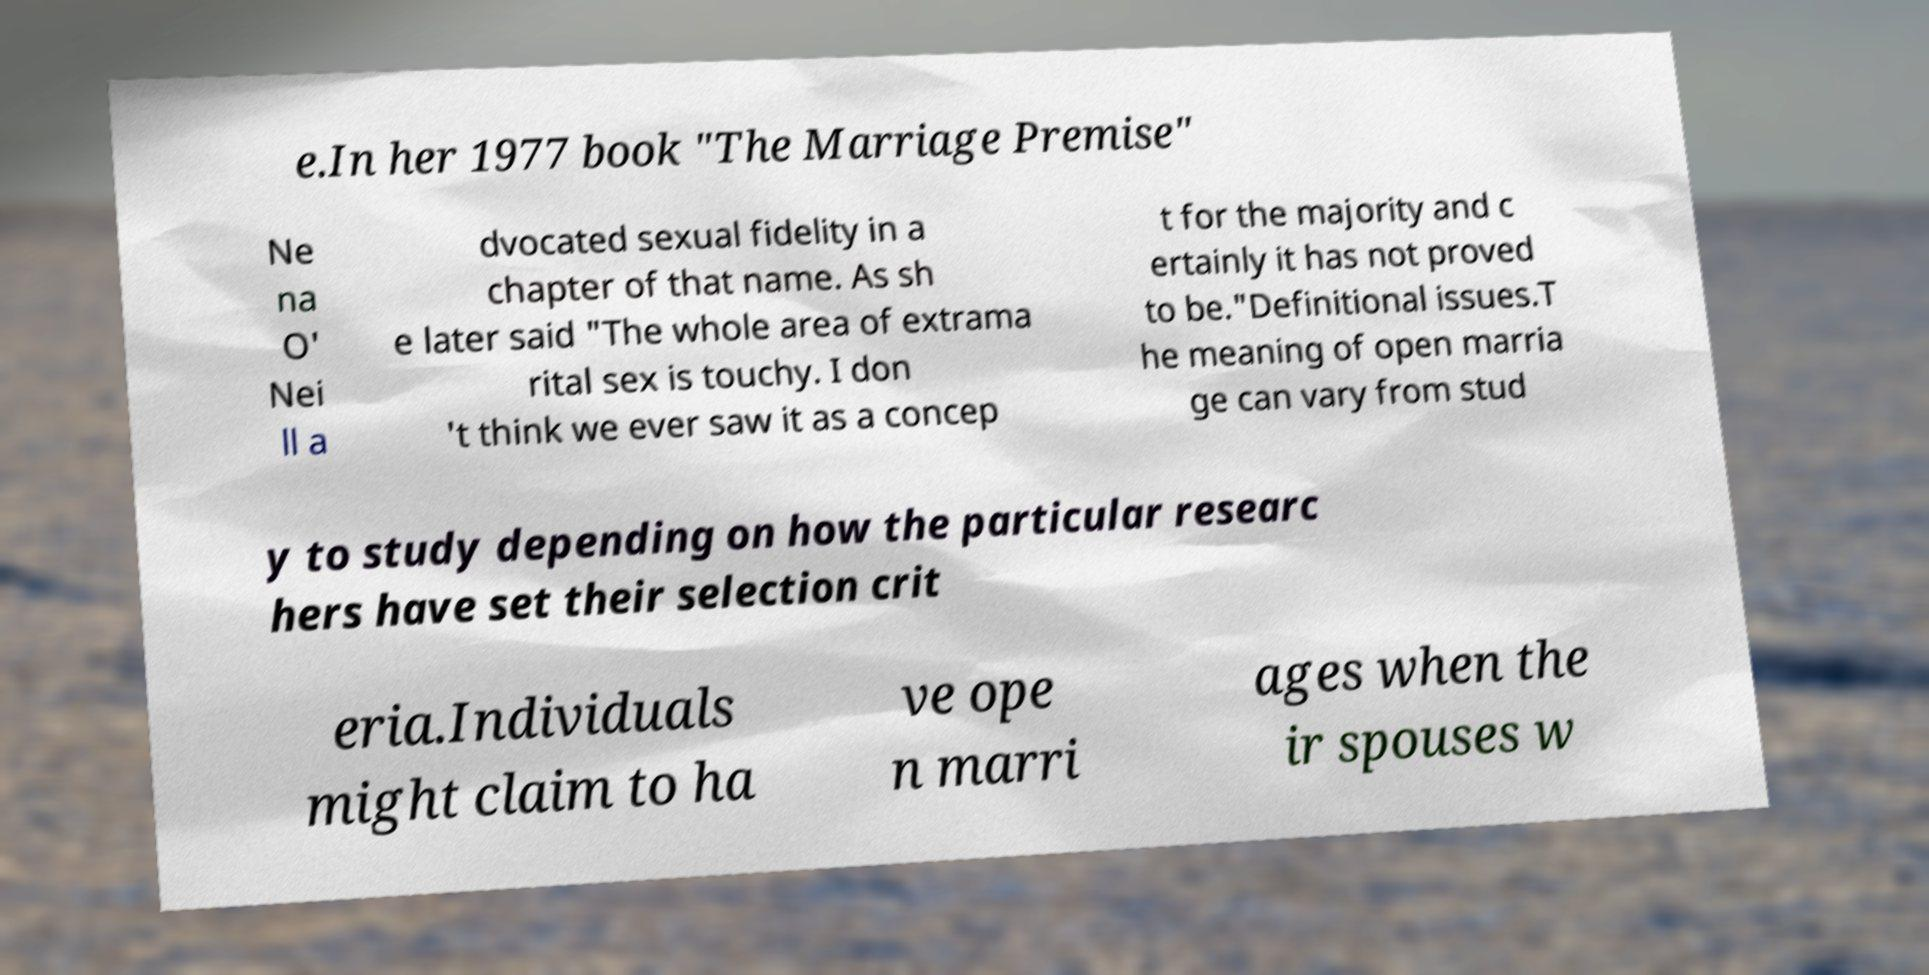Please identify and transcribe the text found in this image. e.In her 1977 book "The Marriage Premise" Ne na O' Nei ll a dvocated sexual fidelity in a chapter of that name. As sh e later said "The whole area of extrama rital sex is touchy. I don 't think we ever saw it as a concep t for the majority and c ertainly it has not proved to be."Definitional issues.T he meaning of open marria ge can vary from stud y to study depending on how the particular researc hers have set their selection crit eria.Individuals might claim to ha ve ope n marri ages when the ir spouses w 